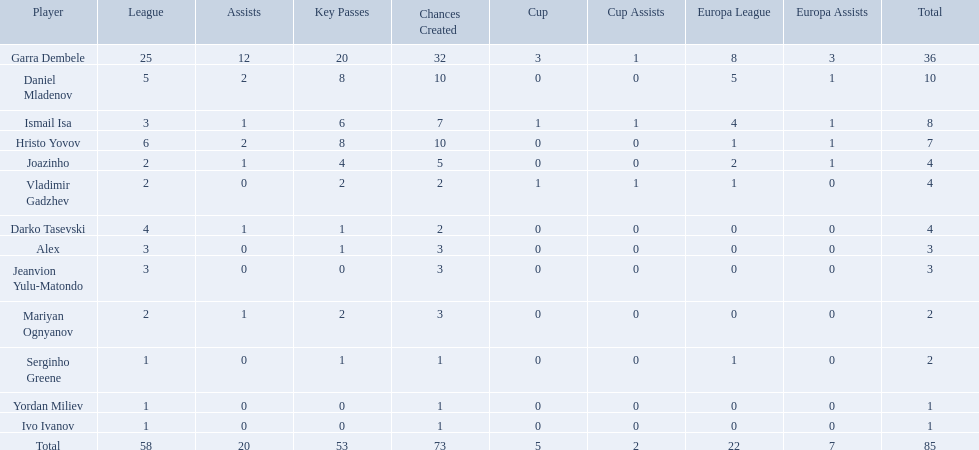What league is 2? 2, 2, 2. Which cup is less than 1? 0, 0. Which total is 2? 2. Who is the player? Mariyan Ognyanov. 